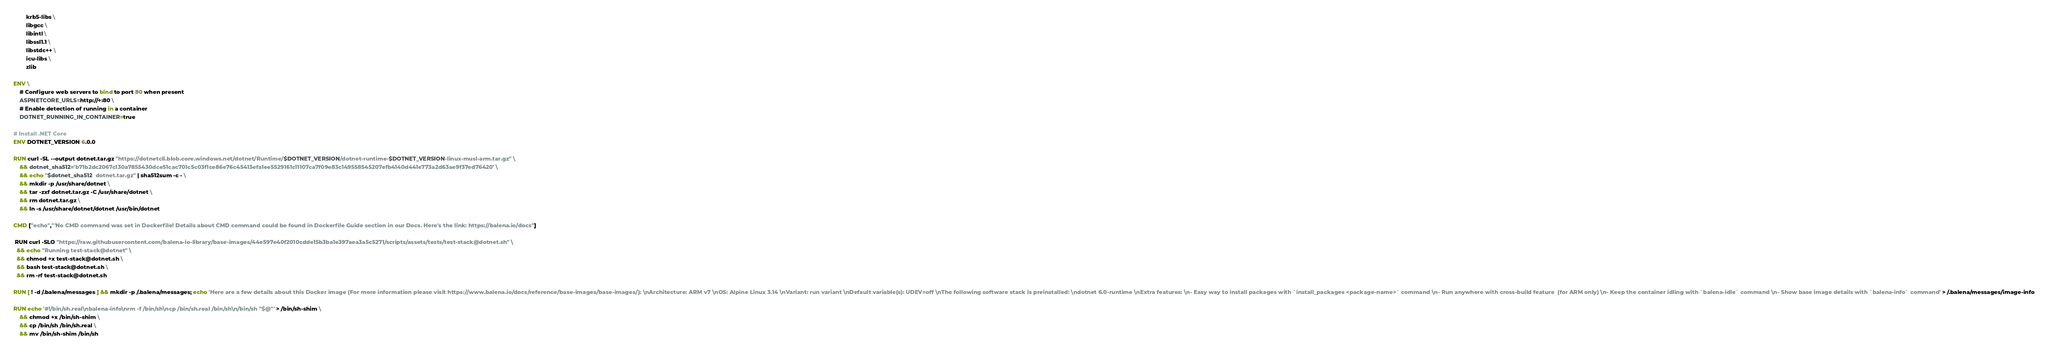Convert code to text. <code><loc_0><loc_0><loc_500><loc_500><_Dockerfile_>        krb5-libs \
        libgcc \
        libintl \
        libssl1.1 \
        libstdc++ \
        icu-libs \
        zlib

ENV \
    # Configure web servers to bind to port 80 when present
    ASPNETCORE_URLS=http://+:80 \
    # Enable detection of running in a container
    DOTNET_RUNNING_IN_CONTAINER=true

# Install .NET Core
ENV DOTNET_VERSION 6.0.0

RUN curl -SL --output dotnet.tar.gz "https://dotnetcli.blob.core.windows.net/dotnet/Runtime/$DOTNET_VERSION/dotnet-runtime-$DOTNET_VERSION-linux-musl-arm.tar.gz" \
    && dotnet_sha512='b71b2dc2067c130a7855430dce51cac701c5c03f1ce86e76c45413efa1ee5529161c11107ca7f09e83c149558545207efb4140d441e773a2d63ae9f37ed76420' \
    && echo "$dotnet_sha512  dotnet.tar.gz" | sha512sum -c - \
    && mkdir -p /usr/share/dotnet \
    && tar -zxf dotnet.tar.gz -C /usr/share/dotnet \
    && rm dotnet.tar.gz \
    && ln -s /usr/share/dotnet/dotnet /usr/bin/dotnet

CMD ["echo","'No CMD command was set in Dockerfile! Details about CMD command could be found in Dockerfile Guide section in our Docs. Here's the link: https://balena.io/docs"]

 RUN curl -SLO "https://raw.githubusercontent.com/balena-io-library/base-images/44e597e40f2010cdde15b3ba1e397aea3a5c5271/scripts/assets/tests/test-stack@dotnet.sh" \
  && echo "Running test-stack@dotnet" \
  && chmod +x test-stack@dotnet.sh \
  && bash test-stack@dotnet.sh \
  && rm -rf test-stack@dotnet.sh 

RUN [ ! -d /.balena/messages ] && mkdir -p /.balena/messages; echo 'Here are a few details about this Docker image (For more information please visit https://www.balena.io/docs/reference/base-images/base-images/): \nArchitecture: ARM v7 \nOS: Alpine Linux 3.14 \nVariant: run variant \nDefault variable(s): UDEV=off \nThe following software stack is preinstalled: \ndotnet 6.0-runtime \nExtra features: \n- Easy way to install packages with `install_packages <package-name>` command \n- Run anywhere with cross-build feature  (for ARM only) \n- Keep the container idling with `balena-idle` command \n- Show base image details with `balena-info` command' > /.balena/messages/image-info

RUN echo '#!/bin/sh.real\nbalena-info\nrm -f /bin/sh\ncp /bin/sh.real /bin/sh\n/bin/sh "$@"' > /bin/sh-shim \
	&& chmod +x /bin/sh-shim \
	&& cp /bin/sh /bin/sh.real \
	&& mv /bin/sh-shim /bin/sh</code> 